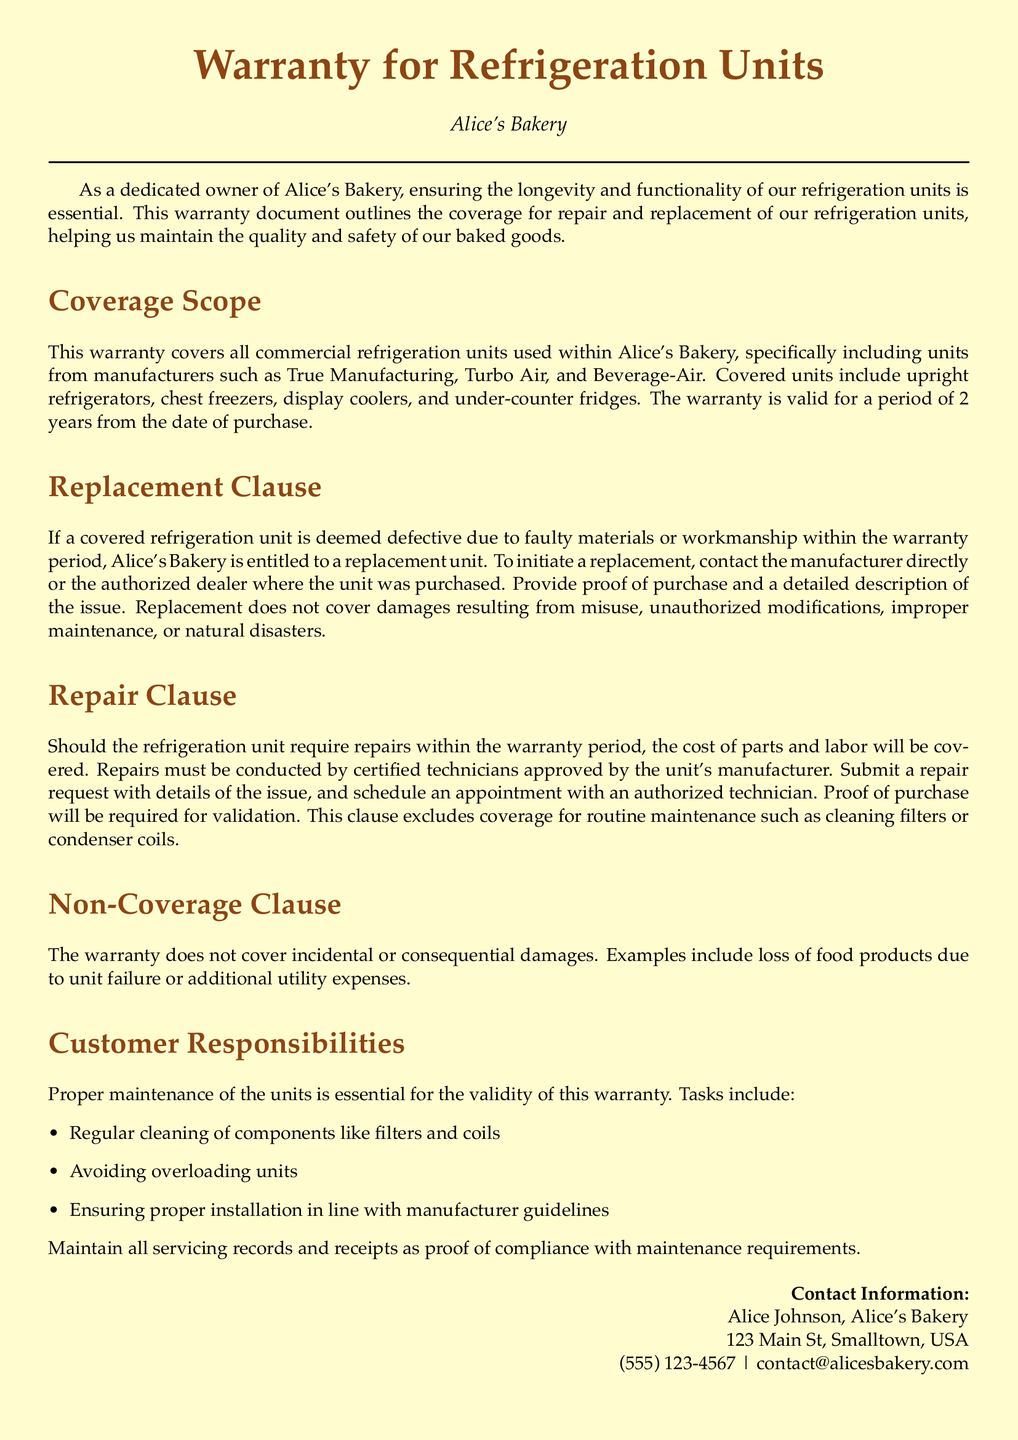What is the warranty period for refrigeration units? The warranty period for the refrigeration units is stated in the document, which specifies a duration of 2 years from the date of purchase.
Answer: 2 years Who is the contact person for warranty-related inquiries? The document provides contact information for warranty-related questions, naming Alice Johnson as the contact person at Alice's Bakery.
Answer: Alice Johnson What types of refrigeration units are covered? The coverage scope section of the document specifies the types of refrigeration units included in the warranty, which are upright refrigerators, chest freezers, display coolers, and under-counter fridges.
Answer: Upright refrigerators, chest freezers, display coolers, under-counter fridges What is required to initiate a replacement? The replacement clause outlines that to initiate a replacement, proof of purchase and a detailed description of the issue must be provided to the manufacturer or authorized dealer.
Answer: Proof of purchase and description of the issue What does the warranty not cover? The non-coverage clause specifies what is excluded from the warranty, stating that it does not cover incidental or consequential damages.
Answer: Incidental or consequential damages What maintenance is required for warranty validity? The customer responsibilities section lists several maintenance tasks, including regular cleaning of components, which is essential for the warranty's validity.
Answer: Regular cleaning of components What type of repairs are covered by the warranty? The repair clause indicates that the warranty covers repairs conducted by certified technicians approved by the unit's manufacturer.
Answer: Repairs by certified technicians Which companies' refrigeration units are mentioned? The coverage scope section mentions specific manufacturers of refrigeration units, which include True Manufacturing, Turbo Air, and Beverage-Air.
Answer: True Manufacturing, Turbo Air, Beverage-Air What should be included in the repair request? The document specifies that a repair request must include details of the issue along with proof of purchase for validation.
Answer: Details of the issue and proof of purchase 